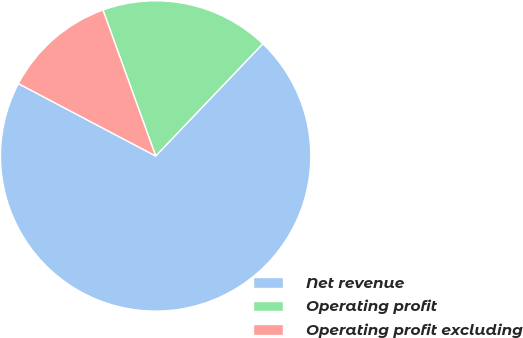<chart> <loc_0><loc_0><loc_500><loc_500><pie_chart><fcel>Net revenue<fcel>Operating profit<fcel>Operating profit excluding<nl><fcel>70.59%<fcel>17.65%<fcel>11.76%<nl></chart> 